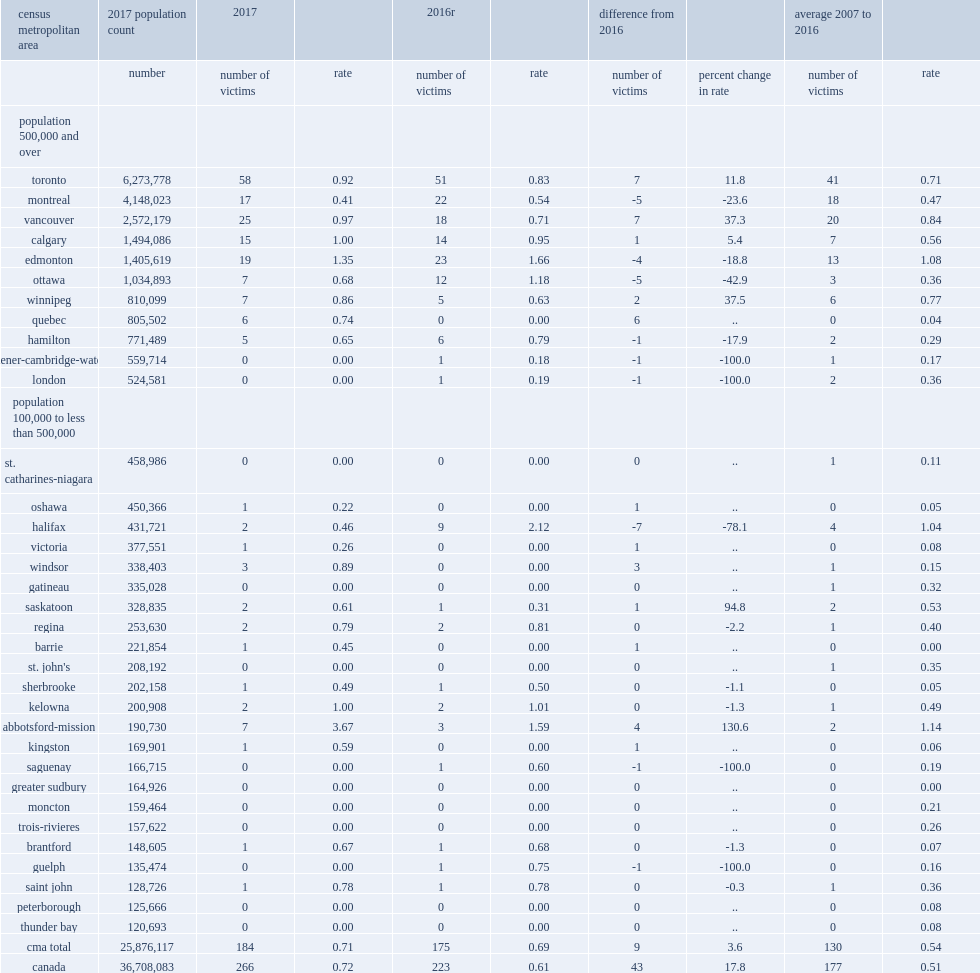Among the cmas, how many victioms did firearm-related homicides predominantly occurr in the five largest cmas of toronto? 58.0. Among the cmas, how many victims did firearm-related homicides predominantly occurr in the cmas of vancouver? 25.0. Among the cmas, how many victims did firearm-related homicides predominantly occurr in the cmas of edmonton? 19.0. Among the cmas, how many victims did firearm-related homicides predominantly occurr in the cmas of montreal? 17.0. Among the cmas, how many victims did firearm-related homicides predominantly occurr in the cmas of calgary? 15.0. With a total of 58, how many more homicides committed with a firearm in toronto in 2017 than in 2016? 7.0. What was the largest declines in firearm-related homicides among the cmas occurred in halifax? -7.0. What was the declines in firearm-related homicides among the cmas occurred in ottawa? -5.0. What was the declines in firearm-related homicides among the cmas occurred in montreal? -5.0. 